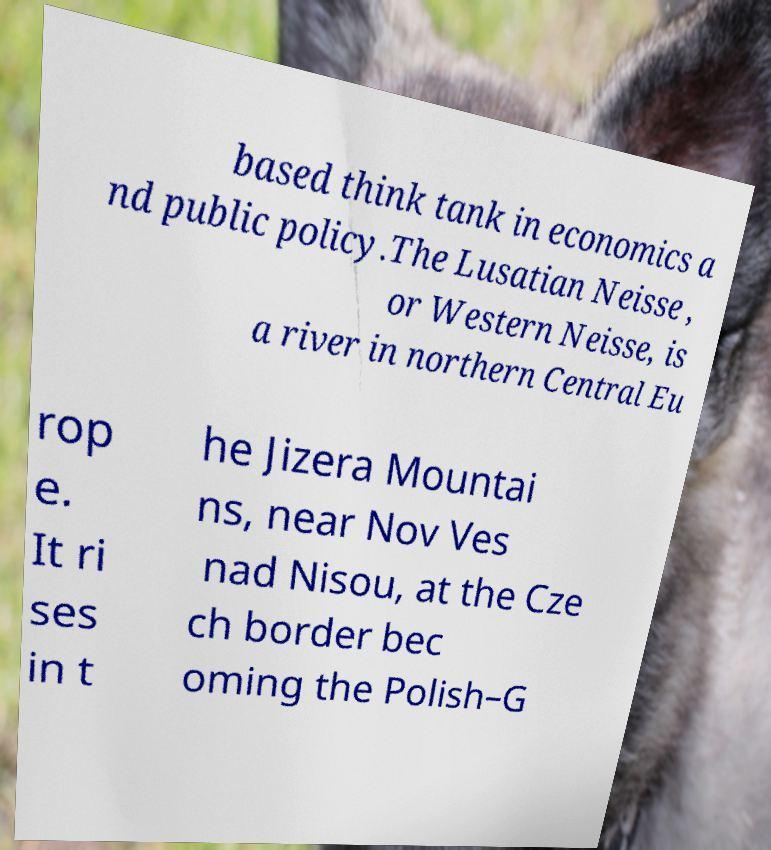Please identify and transcribe the text found in this image. based think tank in economics a nd public policy.The Lusatian Neisse , or Western Neisse, is a river in northern Central Eu rop e. It ri ses in t he Jizera Mountai ns, near Nov Ves nad Nisou, at the Cze ch border bec oming the Polish–G 